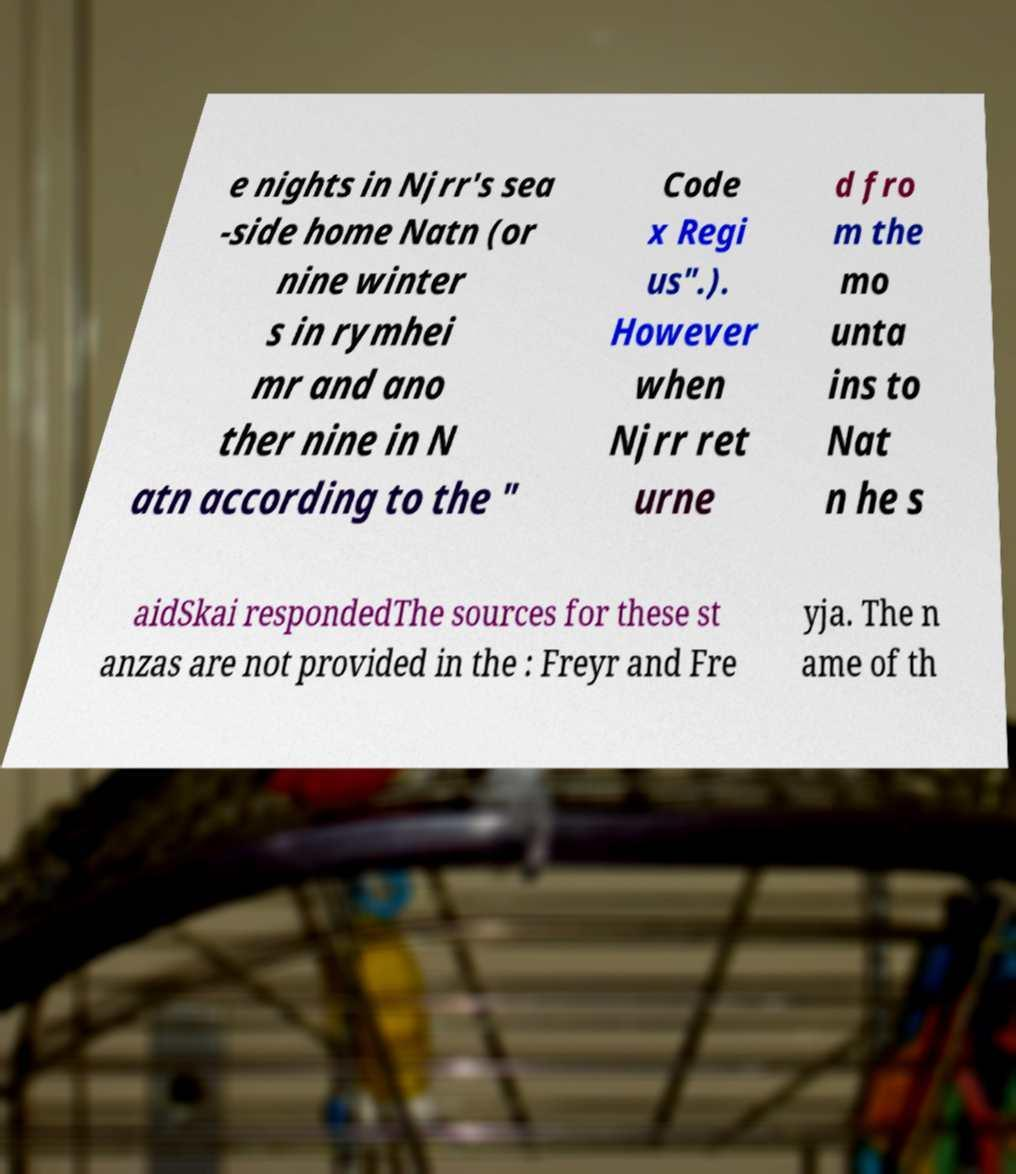For documentation purposes, I need the text within this image transcribed. Could you provide that? e nights in Njrr's sea -side home Natn (or nine winter s in rymhei mr and ano ther nine in N atn according to the " Code x Regi us".). However when Njrr ret urne d fro m the mo unta ins to Nat n he s aidSkai respondedThe sources for these st anzas are not provided in the : Freyr and Fre yja. The n ame of th 